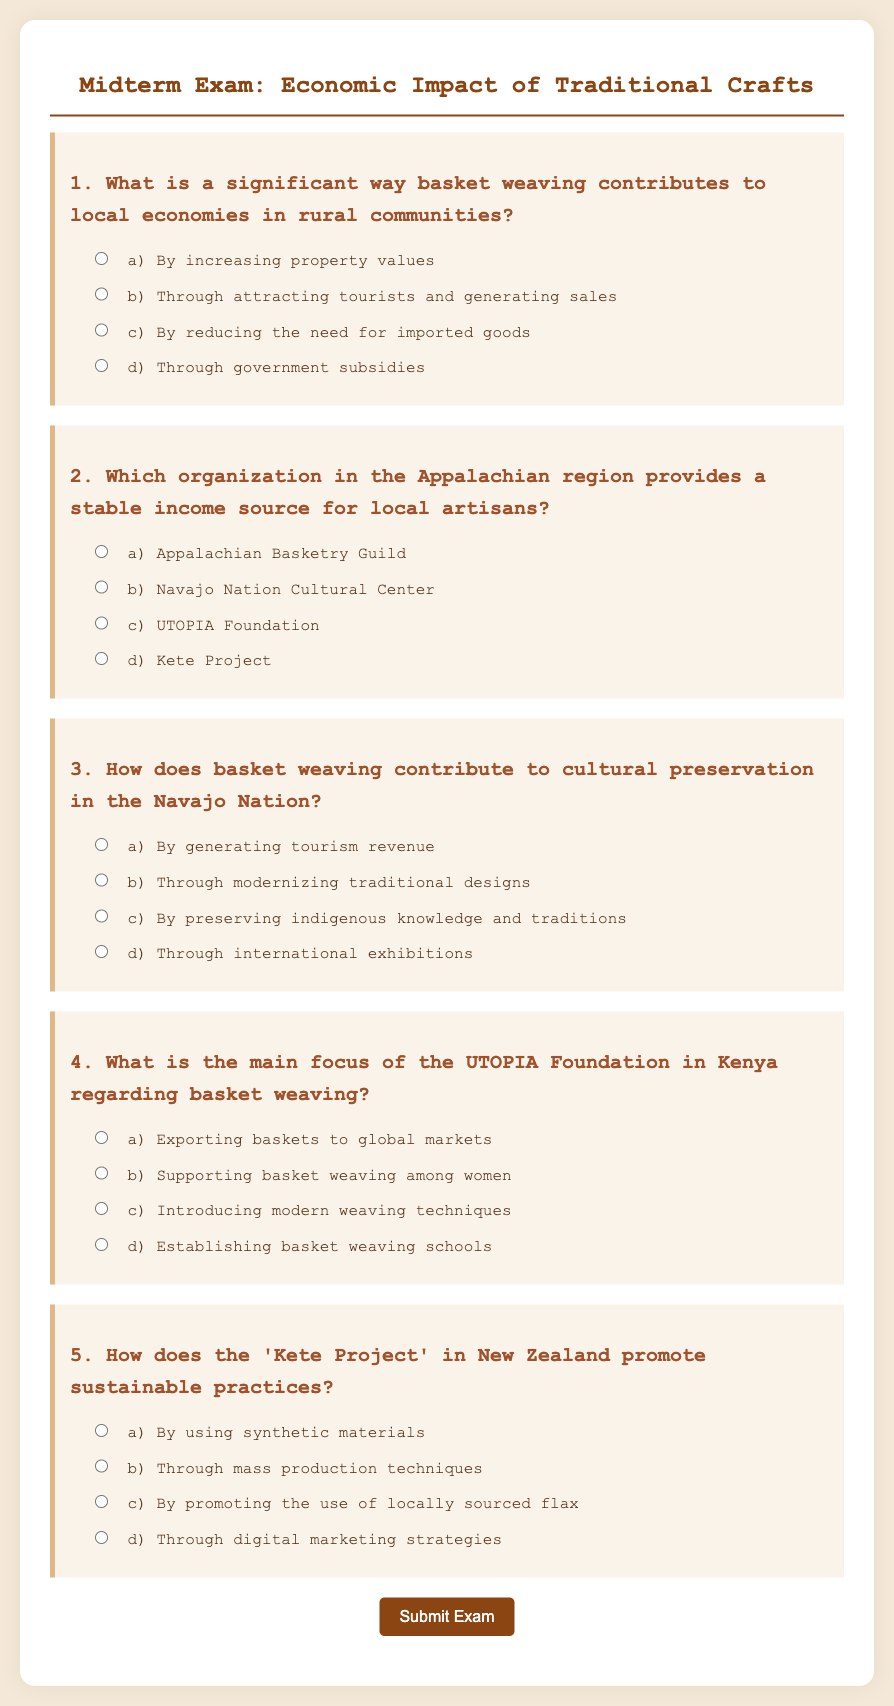What is the title of the exam? The title of the exam is stated at the top of the document, which is "Midterm Exam: Economic Impact of Traditional Crafts."
Answer: Midterm Exam: Economic Impact of Traditional Crafts How many questions are included in the exam? The document contains five questions about the economic impact of traditional crafts.
Answer: Five What is the main focus of the UTOPIA Foundation in Kenya? The document states that the main focus of the UTOPIA Foundation is supporting basket weaving among women.
Answer: Supporting basket weaving among women Which organization is mentioned as providing income in the Appalachian region? The Appalachian Basketry Guild is specified as an organization providing a stable income source for local artisans.
Answer: Appalachian Basketry Guild What is a key benefit of basket weaving in rural communities identified in question 1? The document mentions that basket weaving contributes to local economies by attracting tourists and generating sales.
Answer: Attracting tourists and generating sales How is cultural preservation achieved through basket weaving in the Navajo Nation? The document explains that cultural preservation occurs by preserving indigenous knowledge and traditions as stated in the third question.
Answer: By preserving indigenous knowledge and traditions What sustainable practice is promoted by the Kete Project in New Zealand? The document indicates that the Kete Project promotes the use of locally sourced flax as a sustainable practice.
Answer: By promoting the use of locally sourced flax 